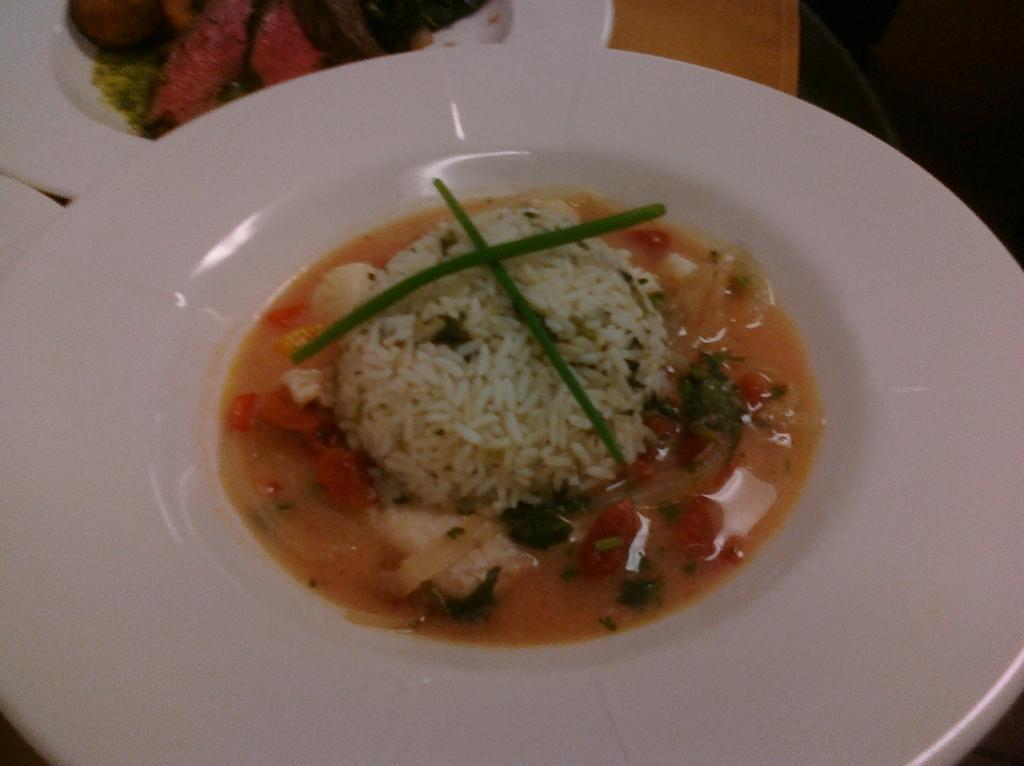How would you summarize this image in a sentence or two? In this image we can see plates containing food placed on the table. 